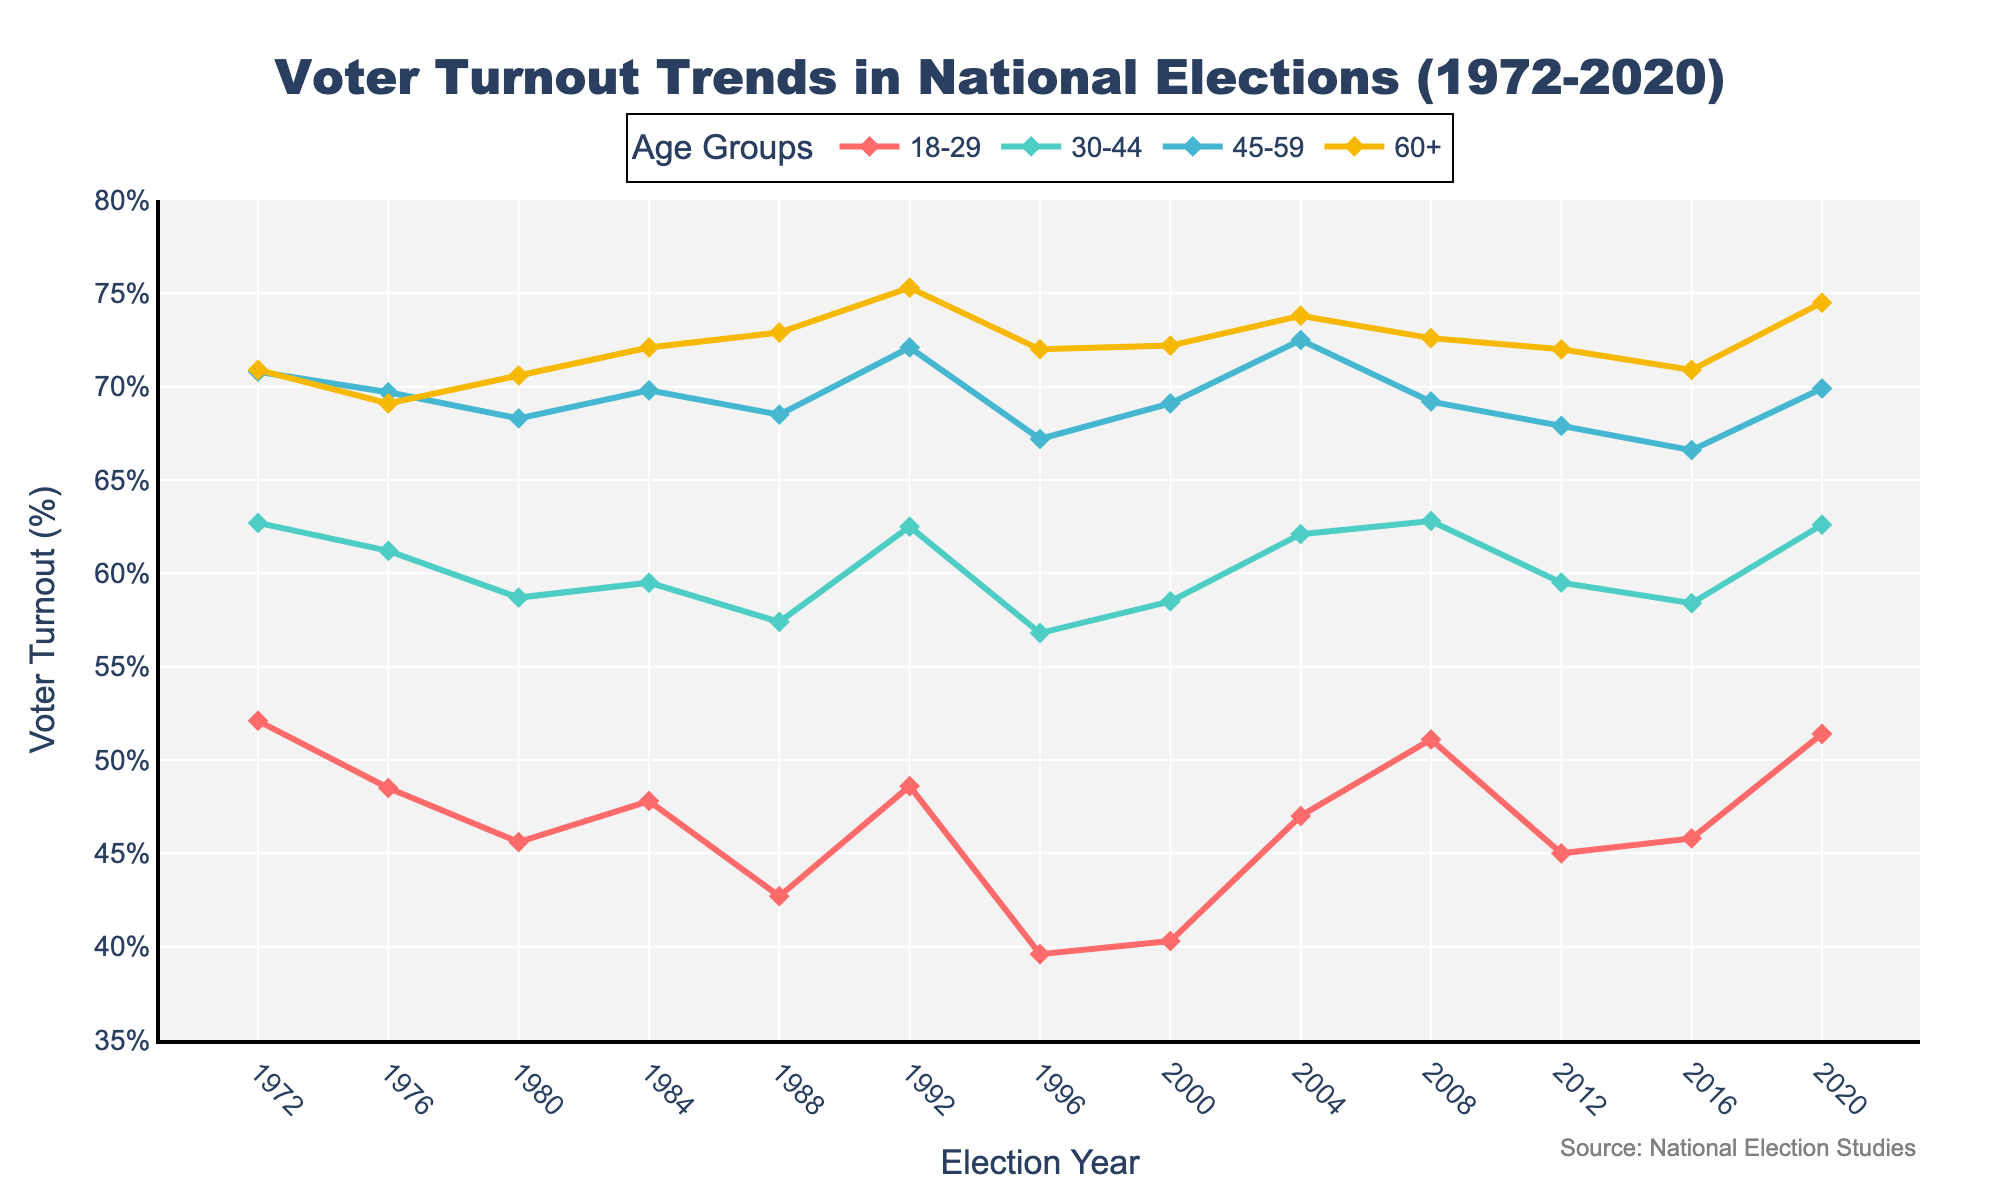What is the overall trend in voter turnout for the age group 18-29 from 1972 to 2020? To determine the trend, look at the data points for the 18-29 age group over the years. The turnout starts at 52.1% in 1972, fluctuates over the years, dipping to its lowest at 39.6% in 1996, and then rises again to 51.4% in 2020. This indicates an overall declining and then recovering trend.
Answer: Declining then recovering Which age group had the highest voter turnout in 2004 and what was the percentage? Refer to the figure and locate the data point for 2004. Compare the voter turnout percentages of all age groups for that year. The 60+ age group had the highest turnout with 73.8%.
Answer: 60+, 73.8% How did the voter turnout for the 30-44 age group change from 1988 to 1992? Identify the voter turnout percentage for the 30-44 age group in 1988 and 1992. The turnout increased from 57.4% in 1988 to 62.5% in 1992. Calculate the difference to confirm the change. 62.5% - 57.4% = 5.1%.
Answer: Increased by 5.1% In which years did the 45-59 age group have a voter turnout higher than 70%? Examine the graph and identify the years where the data points for the 45-59 age group exceed 70%. The years are 1972, 1992, 2004, and 2020.
Answer: 1972, 1992, 2004, 2020 What was the difference in voter turnout between the youngest (18-29) and oldest (60+) age groups in 2020? To find the difference, look at the voter turnout for the 18-29 age group and the 60+ age group in 2020. Subtract the voter turnout of the youngest group from the oldest group's turnout: 74.5% - 51.4% = 23.1%.
Answer: 23.1% What is the average voter turnout for the 30-44 age group over the span of these national elections? Sum the voter turnout percentages for the 30-44 age group across all years and then divide by the number of years (12). The sum is 57.4+62.5+69.8+70.6+72.9+56.8+58.5+62.1+62.8+59.5+58.4+62.6=693.5. The average is 693.5/12 ≈ 57.79%.
Answer: 57.79% In what year did the 60+ age group reach its peak voter turnout and what was the percentage? Determine the highest point on the graph for the 60+ age group. The highest turnout was in 2020, at 74.5%.
Answer: 2020, 74.5% Which age group experienced the most fluctuation in voter turnout over the 50 years? Examine all age groups' lines on the graph. The 18-29 age group shows the most volatility, as indicated by the sharp rises and falls.
Answer: 18-29 How does the voter turnout for the 45-59 age group in 1980 compare to that in 2016? Compare the data points for the 45-59 age group in 1980 and 2016. In 1980, turnout was 68.3%, and in 2016, it was 66.6%, indicating a slight decrease.
Answer: Decreased by 1.7% By how much did the voter turnout for the 60+ age group increase from 1988 to 1992? Find the voter turnout for the 60+ age group in 1988 and 1992. Subtract the 1988 value from the 1992 value: 75.3% - 72.9% = 2.4%.
Answer: 2.4% 